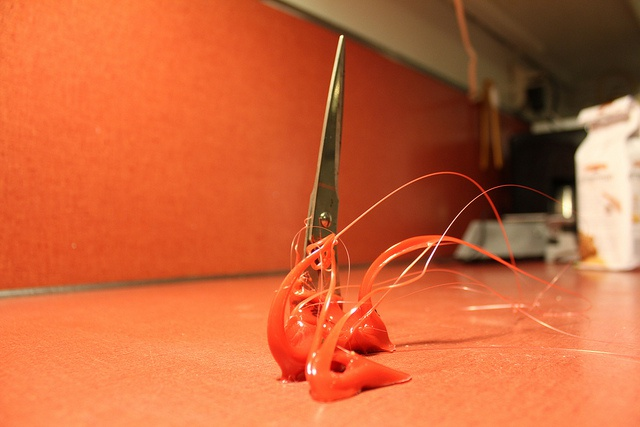Describe the objects in this image and their specific colors. I can see scissors in red, maroon, brown, and tan tones in this image. 